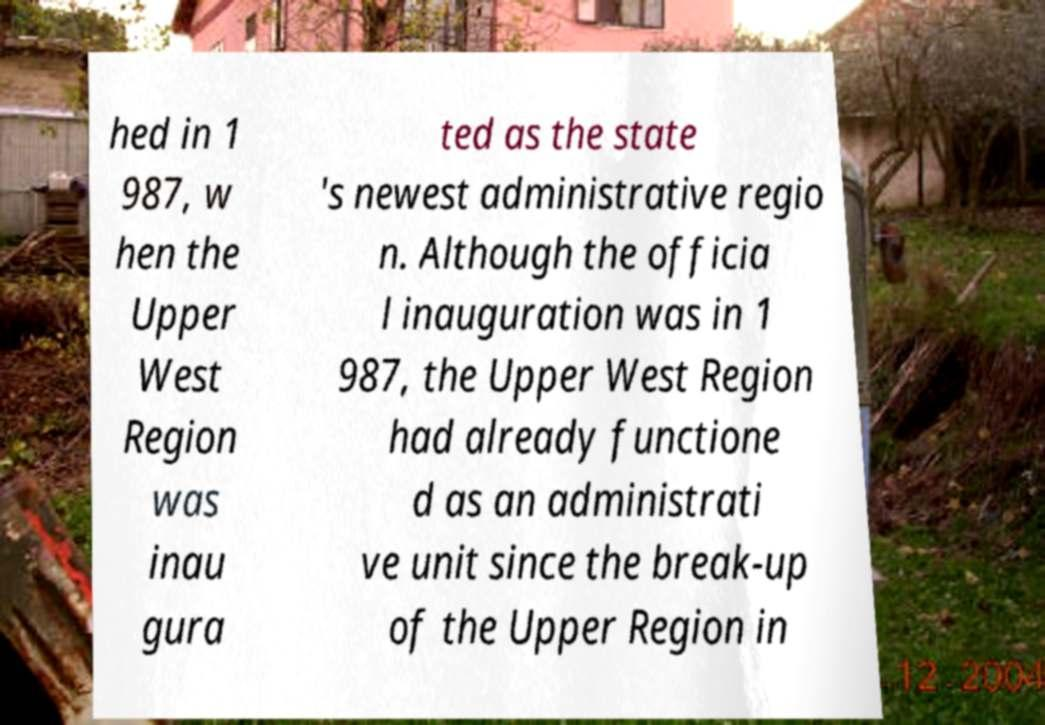There's text embedded in this image that I need extracted. Can you transcribe it verbatim? hed in 1 987, w hen the Upper West Region was inau gura ted as the state 's newest administrative regio n. Although the officia l inauguration was in 1 987, the Upper West Region had already functione d as an administrati ve unit since the break-up of the Upper Region in 